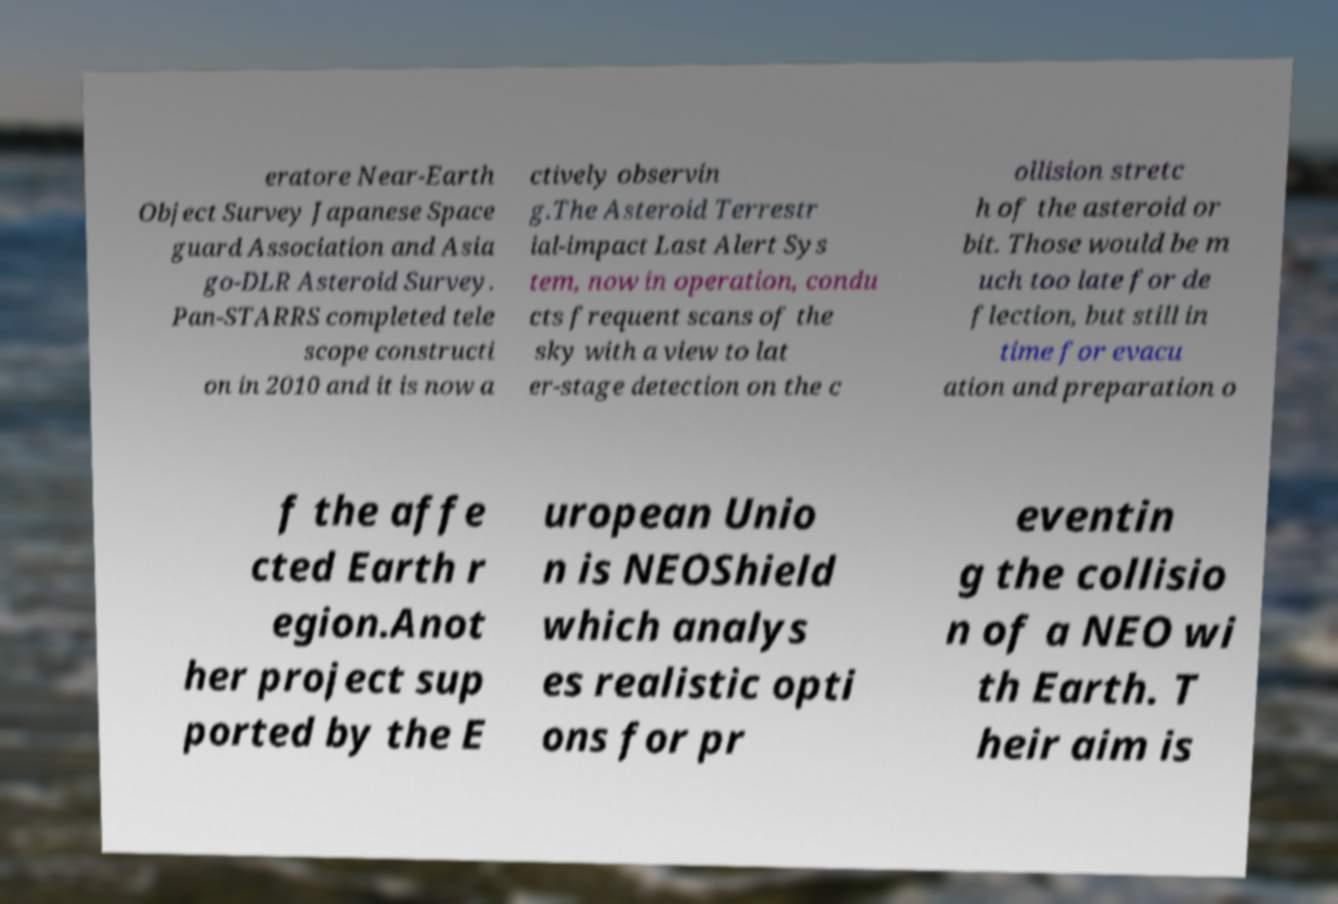Please identify and transcribe the text found in this image. eratore Near-Earth Object Survey Japanese Space guard Association and Asia go-DLR Asteroid Survey. Pan-STARRS completed tele scope constructi on in 2010 and it is now a ctively observin g.The Asteroid Terrestr ial-impact Last Alert Sys tem, now in operation, condu cts frequent scans of the sky with a view to lat er-stage detection on the c ollision stretc h of the asteroid or bit. Those would be m uch too late for de flection, but still in time for evacu ation and preparation o f the affe cted Earth r egion.Anot her project sup ported by the E uropean Unio n is NEOShield which analys es realistic opti ons for pr eventin g the collisio n of a NEO wi th Earth. T heir aim is 